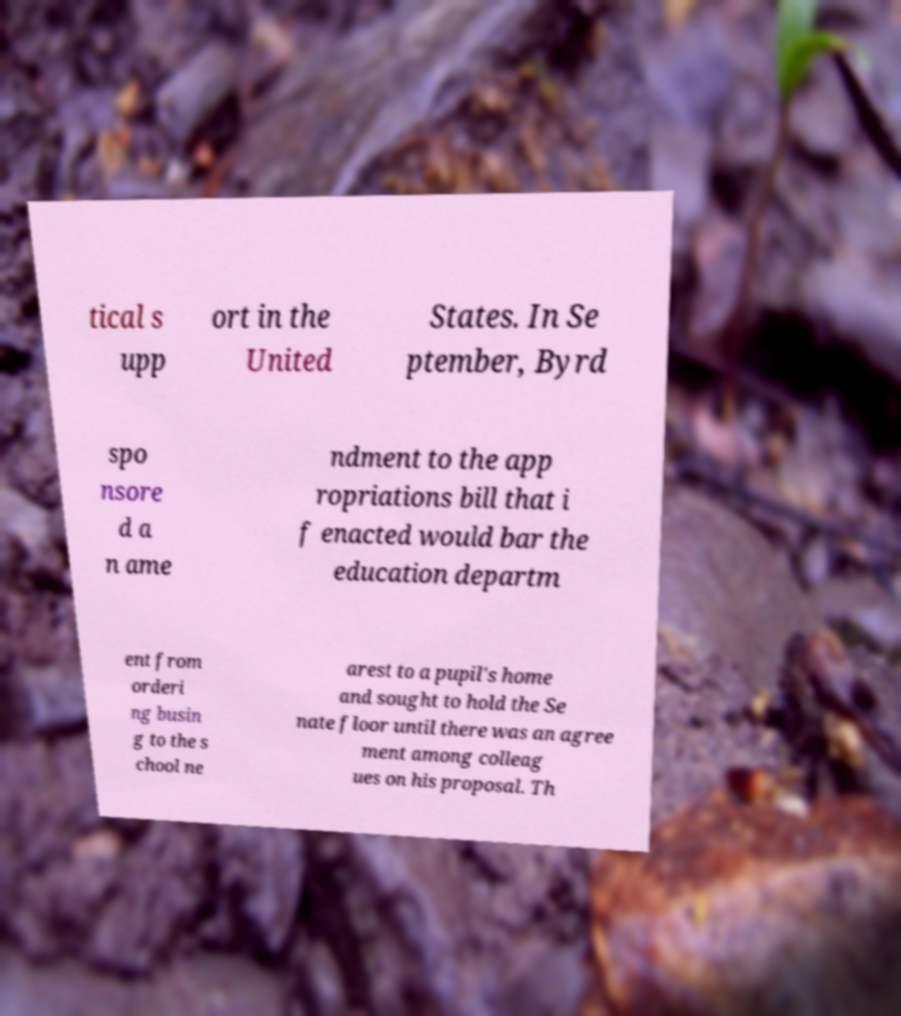What messages or text are displayed in this image? I need them in a readable, typed format. tical s upp ort in the United States. In Se ptember, Byrd spo nsore d a n ame ndment to the app ropriations bill that i f enacted would bar the education departm ent from orderi ng busin g to the s chool ne arest to a pupil's home and sought to hold the Se nate floor until there was an agree ment among colleag ues on his proposal. Th 